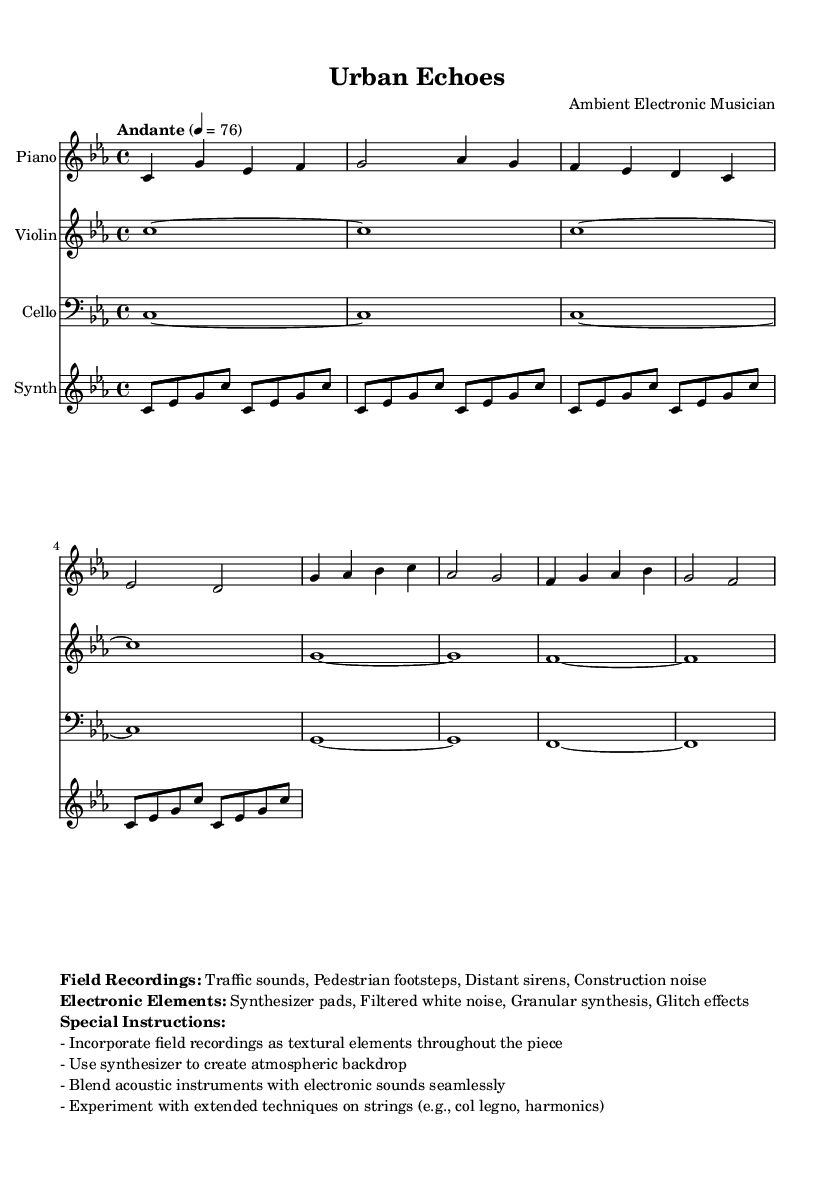What is the key signature of this piece? The key signature is indicated by the two flat symbols, which shows this piece is in C minor.
Answer: C minor What is the time signature of this piece? The time signature is indicated at the beginning of the score as 4/4, meaning there are four beats in a measure.
Answer: 4/4 What is the tempo marking of the piece? The tempo is marked "Andante" with a metronome setting of 76 beats per minute, indicating a moderately slow tempo.
Answer: Andante 4 = 76 What instruments are featured in the score? The score presents four instruments: Piano, Violin, Cello, and Synthesizer, each labeled at the beginning of their respective staves.
Answer: Piano, Violin, Cello, Synthesizer What field recordings are incorporated into the composition? The marked field recordings include "Traffic sounds, Pedestrian footsteps, Distant sirens, Construction noise," which serve as textural elements in the music.
Answer: Traffic sounds, Pedestrian footsteps, Distant sirens, Construction noise How does the synthesizer contribute to the piece? The synthesizer is specified to create an atmospheric backdrop using synthesized pads and effects, blending with acoustic instruments.
Answer: Atmospheric backdrop What kind of extended techniques are suggested for the strings? The piece suggests using extended techniques such as "col legno" and "harmonics," which involve unique playing methods for the string instruments.
Answer: Col legno, harmonics 